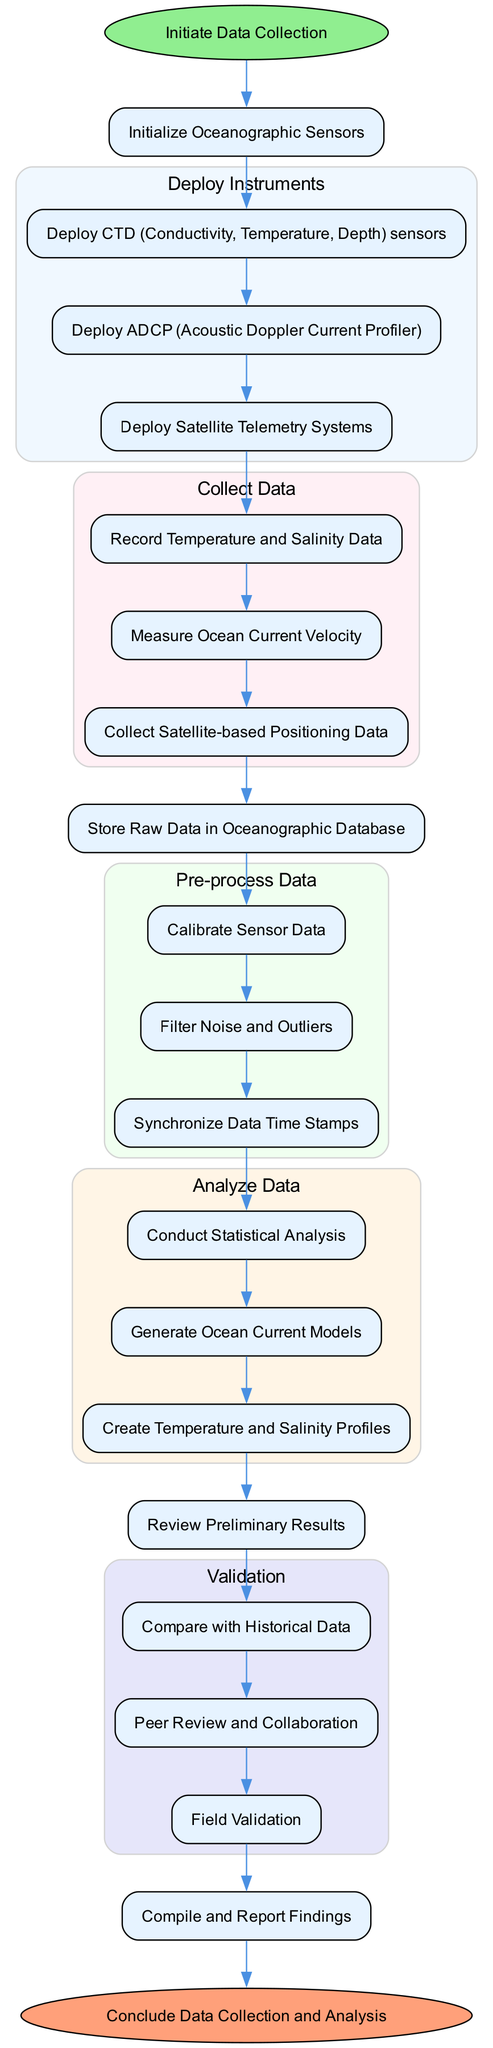What is the initial step in the diagram? The diagram starts with the node labeled "Initiate Data Collection", indicating that this is the first action taken in the process.
Answer: Initiate Data Collection How many different types of instruments are deployed? There are three different types of instruments mentioned in the "Deploy Instruments" section: CTD sensors, ADCP, and Satellite Telemetry Systems. Therefore, the total count is three.
Answer: 3 What does the node "Store Raw Data in Oceanographic Database" connect to? The node "Store Raw Data in Oceanographic Database" is connected to the previous node "Collect Satellite-based Positioning Data", indicating that it follows the collection of data.
Answer: Collect Satellite-based Positioning Data What actions are taken during data pre-processing? Three actions are present: Calibrate Sensor Data, Filter Noise and Outliers, and Synchronize Data Time Stamps. These actions are grouped together to show what happens before analysis.
Answer: Calibrate Sensor Data, Filter Noise and Outliers, Synchronize Data Time Stamps What is the relationship between "Review Preliminary Results" and "Compare with Historical Data"? "Review Preliminary Results" directly leads to the validation phase, where "Compare with Historical Data" is one of the tasks. This indicates that reviewing results is a precursor to comparing data.
Answer: Review Preliminary Results → Compare with Historical Data After data collection, how many distinct data analyses are conducted? There are three distinct analyses described: Conduct Statistical Analysis, Generate Ocean Current Models, and Create Temperature and Salinity Profiles. This shows the variety of analyses performed on the pre-processed data.
Answer: 3 What is the last action before concluding the data collection and analysis process? The last action noted in the diagram before reaching the "Finish" node is "Compile and Report Findings". This indicates that reporting findings is the final step of the data processing workflow.
Answer: Compile and Report Findings Which node comes directly after "Analyze Data"? The node that comes immediately after "Analyze Data" is "Review Preliminary Results", indicating that once data is analyzed, it undergoes a review process.
Answer: Review Preliminary Results 